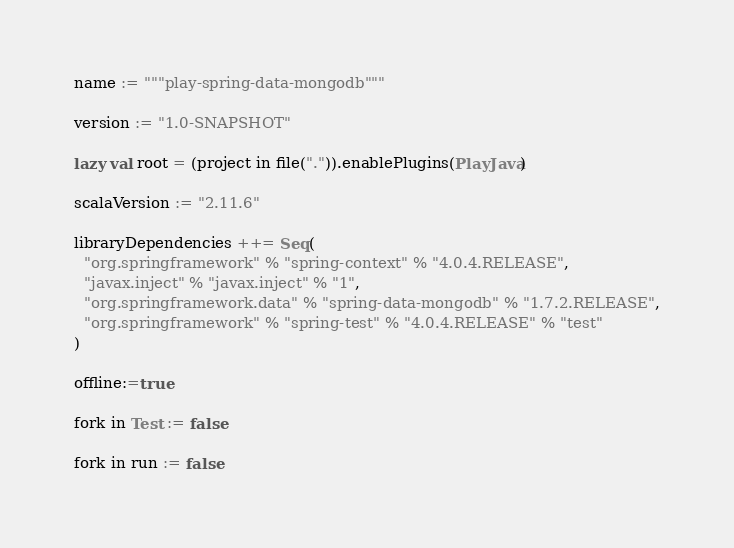Convert code to text. <code><loc_0><loc_0><loc_500><loc_500><_Scala_>name := """play-spring-data-mongodb"""

version := "1.0-SNAPSHOT"

lazy val root = (project in file(".")).enablePlugins(PlayJava)

scalaVersion := "2.11.6"

libraryDependencies ++= Seq(
  "org.springframework" % "spring-context" % "4.0.4.RELEASE",
  "javax.inject" % "javax.inject" % "1",
  "org.springframework.data" % "spring-data-mongodb" % "1.7.2.RELEASE",
  "org.springframework" % "spring-test" % "4.0.4.RELEASE" % "test"
)

offline:=true

fork in Test := false

fork in run := false</code> 